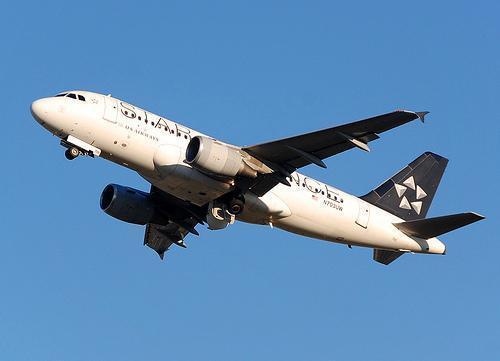How many engines does the airplane have?
Give a very brief answer. 2. How many triangles are on the tailfin?
Give a very brief answer. 5. 